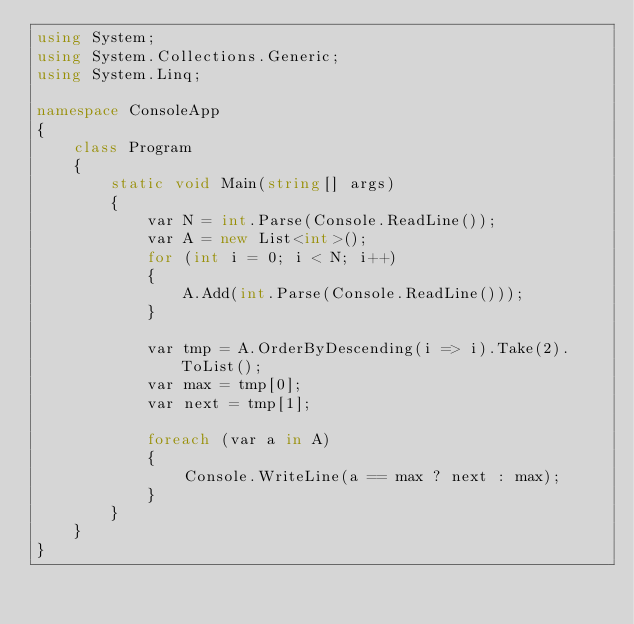Convert code to text. <code><loc_0><loc_0><loc_500><loc_500><_C#_>using System;
using System.Collections.Generic;
using System.Linq;

namespace ConsoleApp
{
    class Program
    {
        static void Main(string[] args)
        {
            var N = int.Parse(Console.ReadLine());
            var A = new List<int>();
            for (int i = 0; i < N; i++)
            {
                A.Add(int.Parse(Console.ReadLine()));
            }

            var tmp = A.OrderByDescending(i => i).Take(2).ToList();
            var max = tmp[0];
            var next = tmp[1];

            foreach (var a in A)
            {
                Console.WriteLine(a == max ? next : max);
            }
        }
    }
}
</code> 